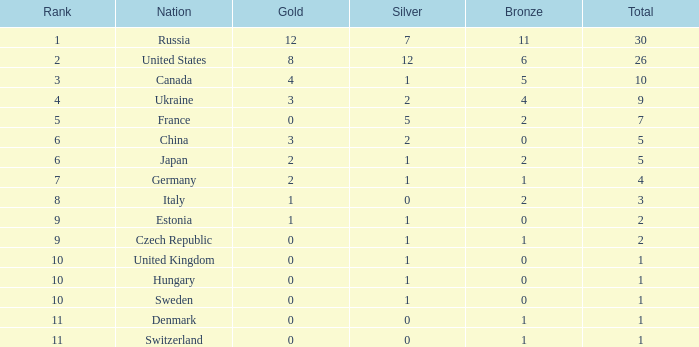How many silver medals does hungary have with a national rank higher than 10? 0.0. 